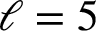<formula> <loc_0><loc_0><loc_500><loc_500>\ell = 5</formula> 